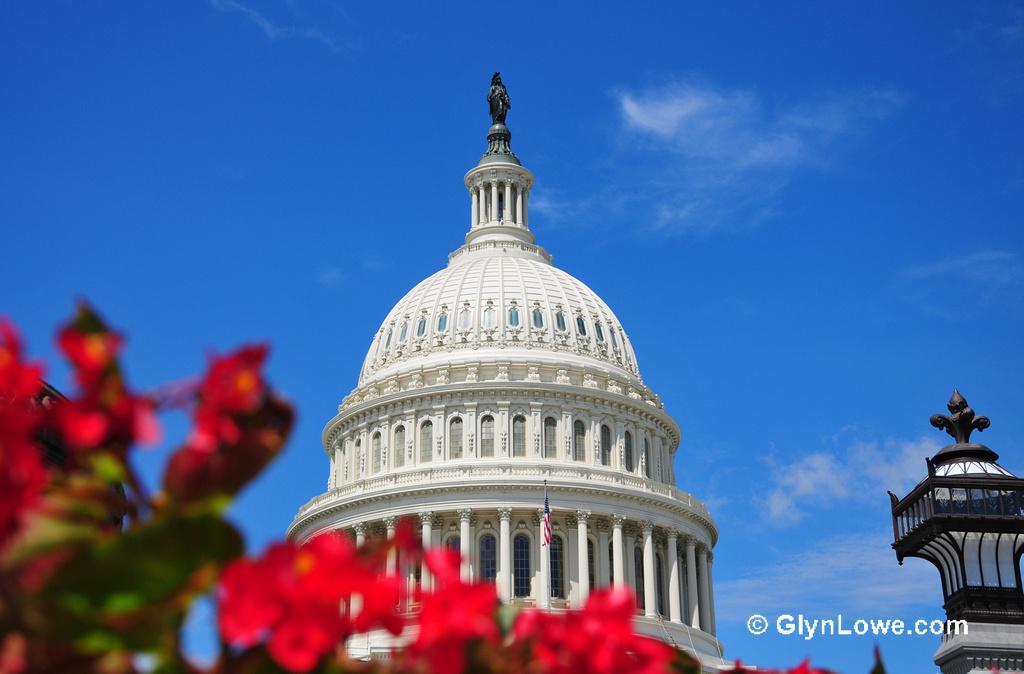Can you describe this image briefly? There is a dome in the center of the image and there is a statue on it and there is a lamp pole in the bottom right side, there are flowers at the bottom side and there is sky in the background area. 